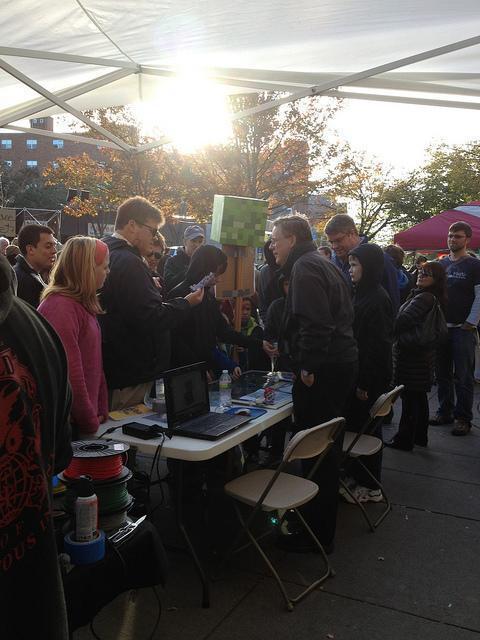How many people are sitting down?
Give a very brief answer. 0. How many people are there?
Give a very brief answer. 10. How many chairs are visible?
Give a very brief answer. 2. How many people is this bed designed for?
Give a very brief answer. 0. 